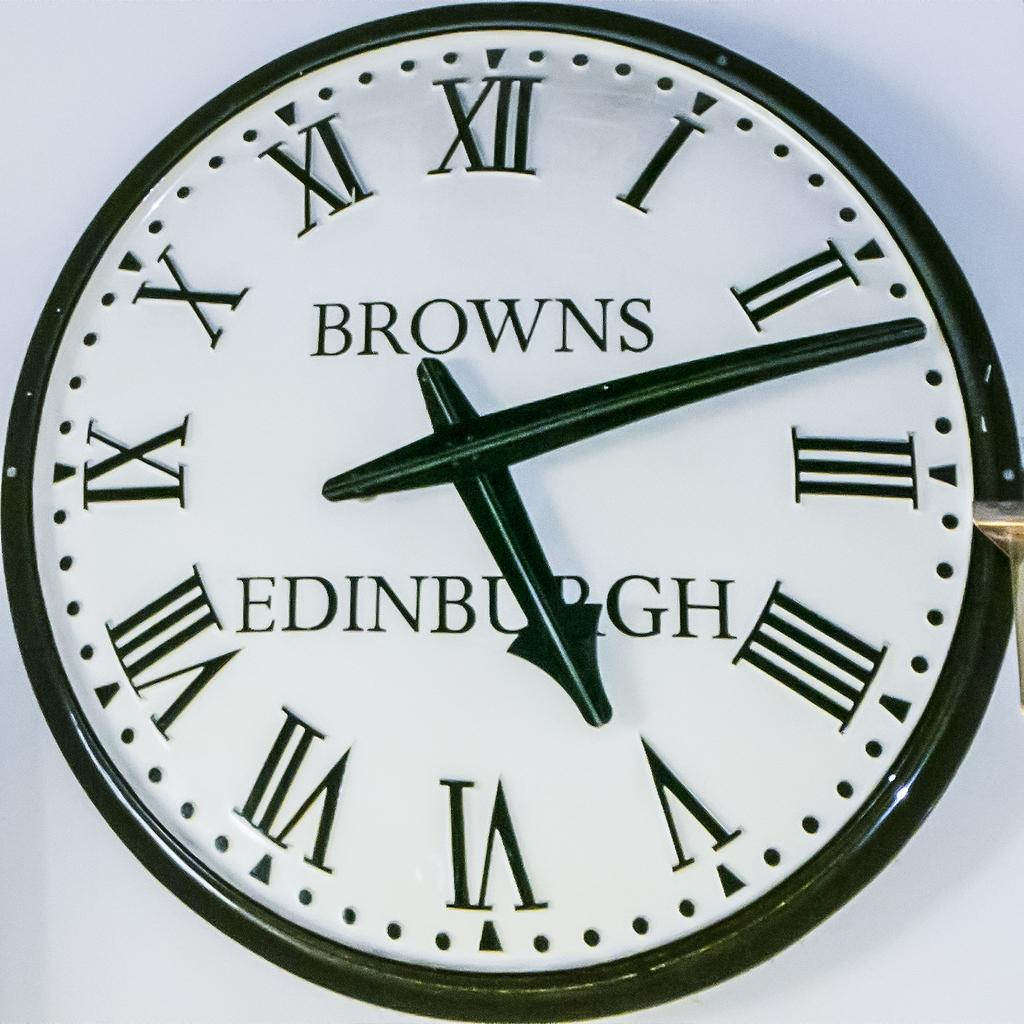<image>
Render a clear and concise summary of the photo. the word browns that is on a clock 